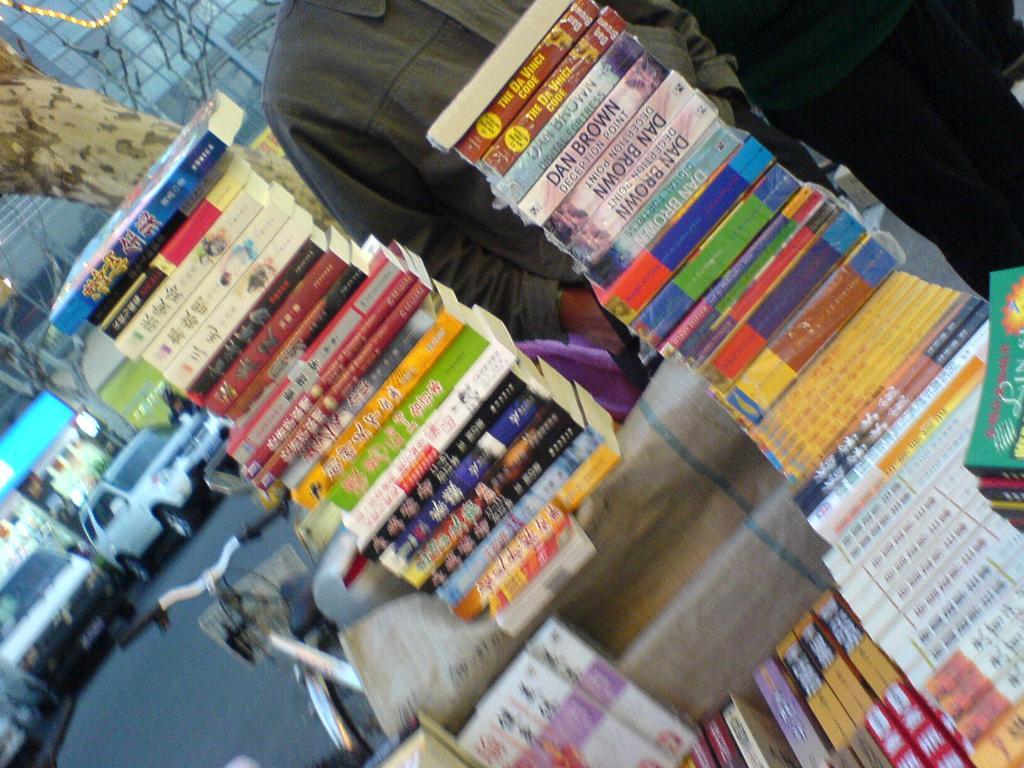Is there a dan brown book?
Ensure brevity in your answer.  Yes. 